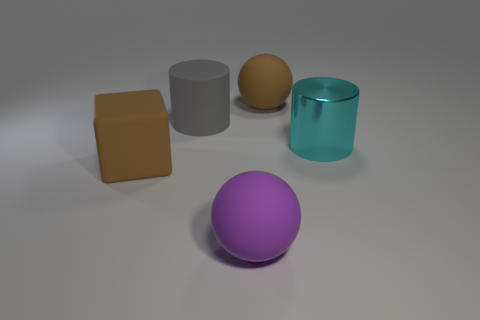Subtract all brown spheres. How many spheres are left? 1 Subtract all balls. How many objects are left? 3 Add 4 tiny purple matte cylinders. How many objects exist? 9 Add 5 gray rubber cylinders. How many gray rubber cylinders are left? 6 Add 5 tiny green rubber spheres. How many tiny green rubber spheres exist? 5 Subtract 1 brown spheres. How many objects are left? 4 Subtract 1 cylinders. How many cylinders are left? 1 Subtract all gray balls. Subtract all purple cylinders. How many balls are left? 2 Subtract all yellow cylinders. How many green spheres are left? 0 Subtract all large rubber cylinders. Subtract all green metal balls. How many objects are left? 4 